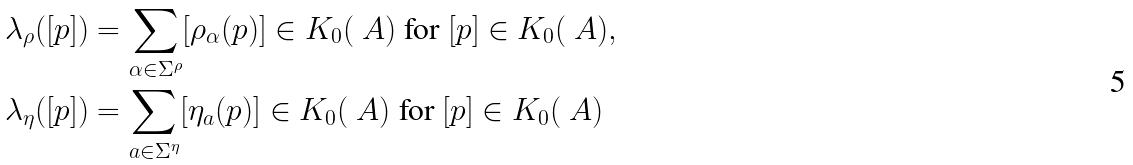Convert formula to latex. <formula><loc_0><loc_0><loc_500><loc_500>\lambda _ { \rho } ( [ p ] ) & = \sum _ { \alpha \in \Sigma ^ { \rho } } [ \rho _ { \alpha } ( p ) ] \in K _ { 0 } ( \ A ) \text { for } [ p ] \in K _ { 0 } ( \ A ) , \\ \lambda _ { \eta } ( [ p ] ) & = \sum _ { a \in \Sigma ^ { \eta } } [ \eta _ { a } ( p ) ] \in K _ { 0 } ( \ A ) \text { for } [ p ] \in K _ { 0 } ( \ A )</formula> 